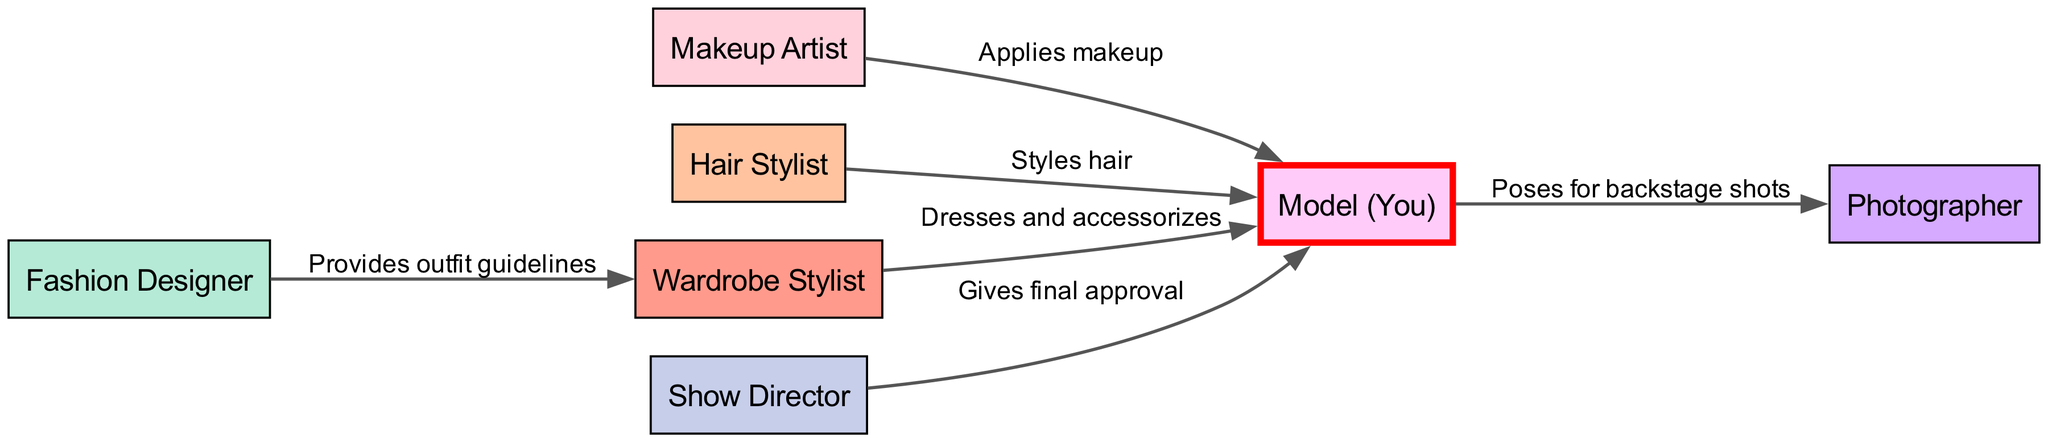What are the main roles involved in the makeup and styling process? The diagram lists seven nodes representing key roles: Makeup Artist, Hair Stylist, Wardrobe Stylist, Model (You), Photographer, Fashion Designer, and Show Director.
Answer: Makeup Artist, Hair Stylist, Wardrobe Stylist, Model (You), Photographer, Fashion Designer, Show Director What does the Hair Stylist do? The diagram indicates that the Hair Stylist's role is labeled as "Styles hair," showing the direct relationship to the Model (You).
Answer: Styles hair How many edges are there in the diagram? By counting the connections (edges) between the nodes, there are a total of six distinct edges in the diagram, each representing a specific action or relationship.
Answer: 6 Who gives final approval to the Model (You)? The edge labeled "Gives final approval" connects the Show Director to the Model (You), indicating that the Show Director is responsible for this final decision.
Answer: Show Director What action does the Makeup Artist perform? The edge between the Makeup Artist and the Model (You) is labeled "Applies makeup," clearly showing the action performed by the Makeup Artist.
Answer: Applies makeup Which role is responsible for providing outfit guidelines? The Fashion Designer is connected to the Wardrobe Stylist with the label "Provides outfit guidelines," which defines this responsibility within the diagram.
Answer: Fashion Designer What is the relationship between the Model (You) and the Photographer? The edge labeled "Poses for backstage shots" identifies the action and connection between the Model (You) and the Photographer, describing the interaction.
Answer: Poses for backstage shots Which stylist is responsible for dressing and accessorizing the Model (You)? The Wardrobe Stylist has a direct connection labeled "Dresses and accessorizes" leading to the Model (You), indicating this specific responsibility.
Answer: Wardrobe Stylist How many roles have a direct influence on the Model (You)? The Model (You) has direct connections from Makeup Artist, Hair Stylist, Wardrobe Stylist, and Show Director, which makes it a total of four roles influencing the Model.
Answer: 4 